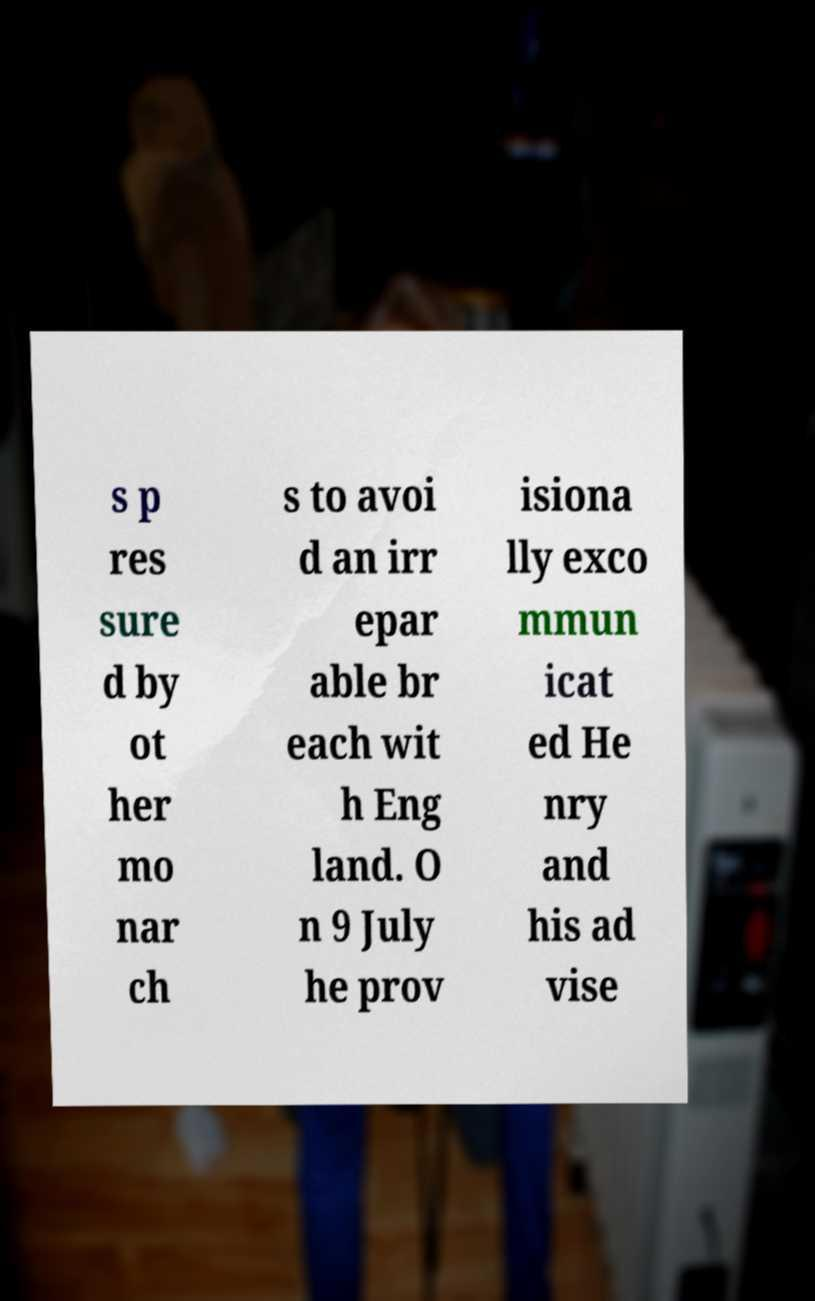Can you accurately transcribe the text from the provided image for me? s p res sure d by ot her mo nar ch s to avoi d an irr epar able br each wit h Eng land. O n 9 July he prov isiona lly exco mmun icat ed He nry and his ad vise 